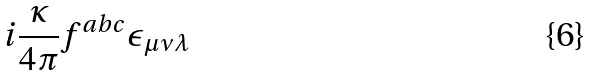<formula> <loc_0><loc_0><loc_500><loc_500>i \frac { \kappa } { 4 \pi } f ^ { a b c } \epsilon _ { \mu \nu \lambda }</formula> 